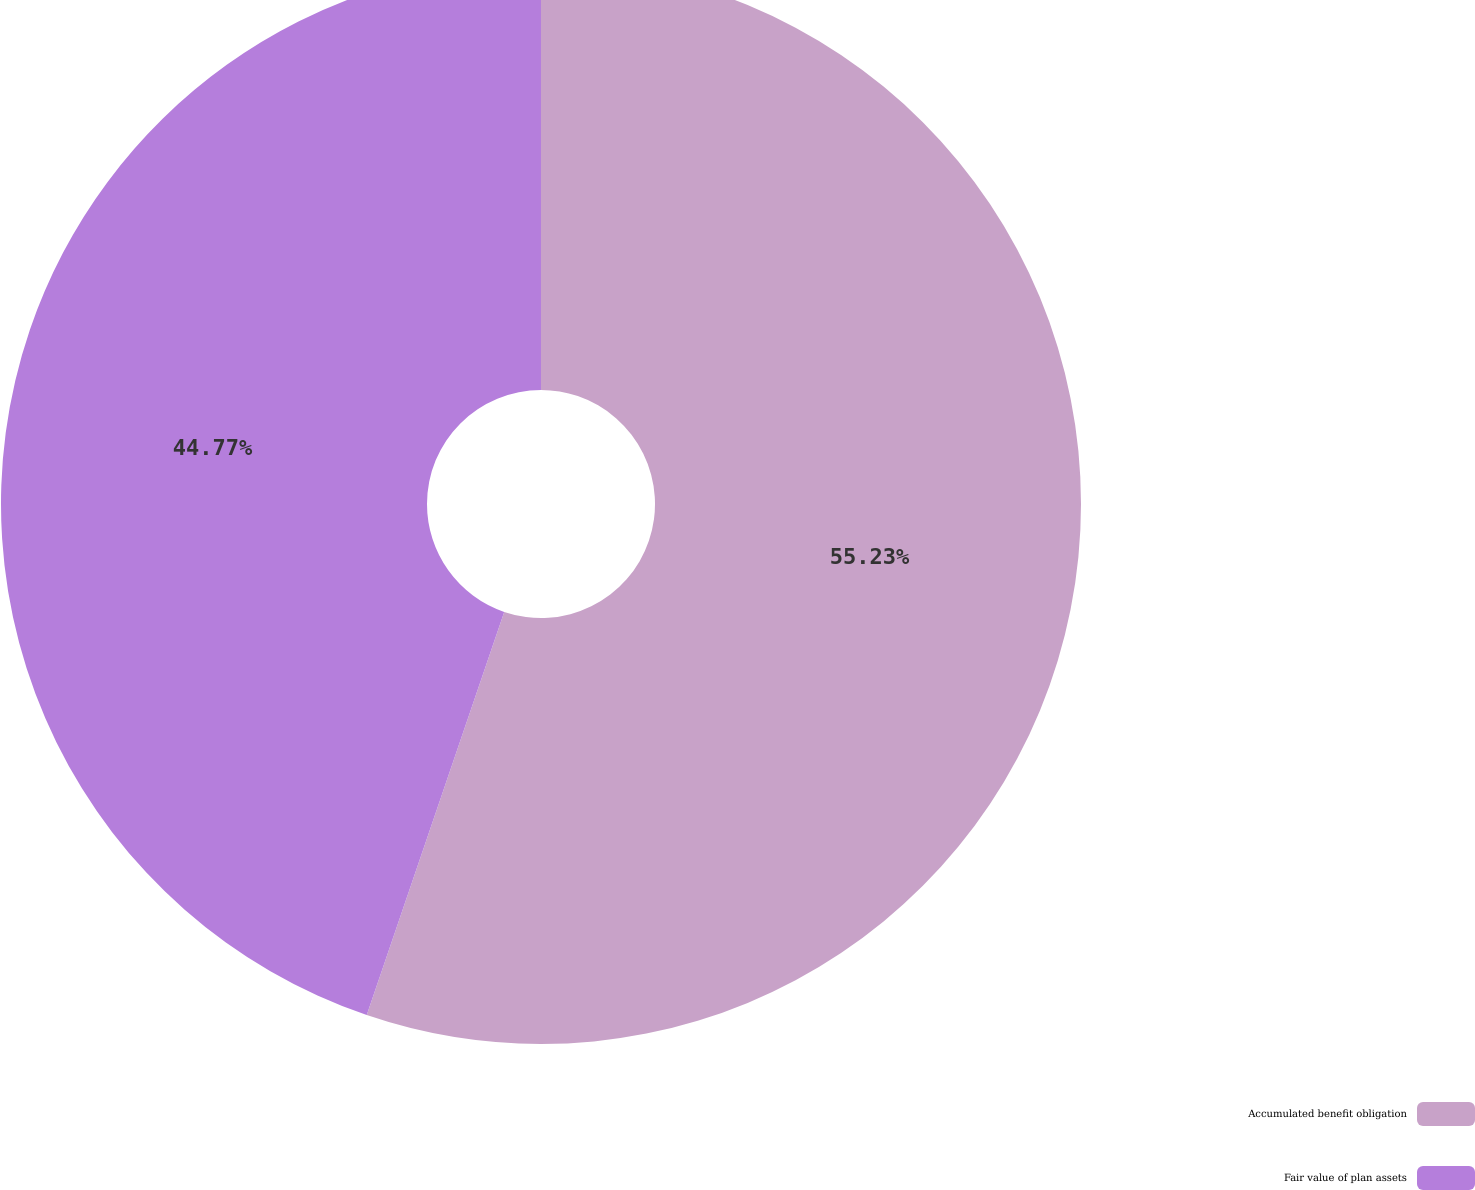<chart> <loc_0><loc_0><loc_500><loc_500><pie_chart><fcel>Accumulated benefit obligation<fcel>Fair value of plan assets<nl><fcel>55.23%<fcel>44.77%<nl></chart> 